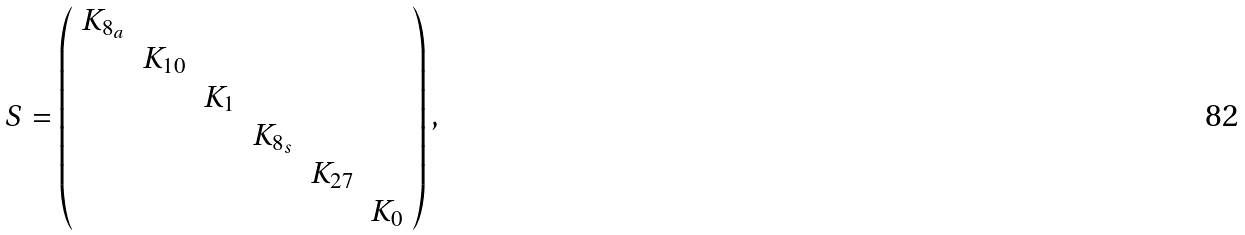<formula> <loc_0><loc_0><loc_500><loc_500>S = \left ( \begin{array} { c c c c c c } K _ { 8 _ { a } } \\ & K _ { 1 0 } \\ & & K _ { 1 } \\ & & & K _ { 8 _ { s } } \\ & & & & K _ { 2 7 } \\ & & & & & K _ { 0 } \end{array} \right ) ,</formula> 